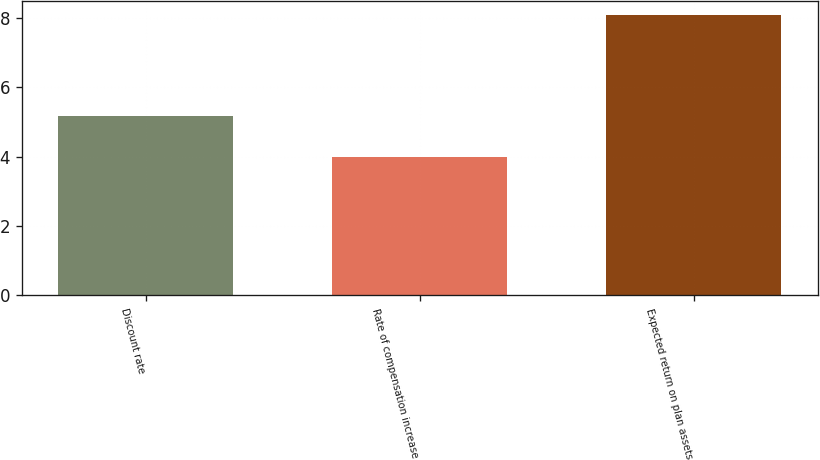<chart> <loc_0><loc_0><loc_500><loc_500><bar_chart><fcel>Discount rate<fcel>Rate of compensation increase<fcel>Expected return on plan assets<nl><fcel>5.17<fcel>4<fcel>8.09<nl></chart> 